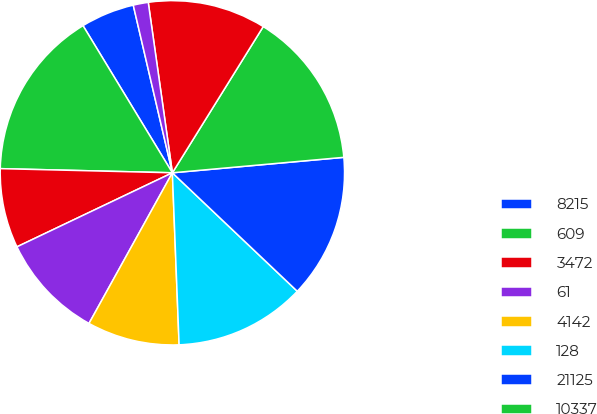Convert chart to OTSL. <chart><loc_0><loc_0><loc_500><loc_500><pie_chart><fcel>8215<fcel>609<fcel>3472<fcel>61<fcel>4142<fcel>128<fcel>21125<fcel>10337<fcel>52007<fcel>23532<nl><fcel>5.04%<fcel>15.93%<fcel>7.46%<fcel>9.88%<fcel>8.67%<fcel>12.3%<fcel>13.51%<fcel>14.72%<fcel>11.09%<fcel>1.41%<nl></chart> 